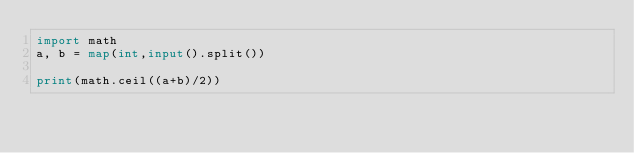<code> <loc_0><loc_0><loc_500><loc_500><_Python_>import math
a, b = map(int,input().split())

print(math.ceil((a+b)/2))
</code> 